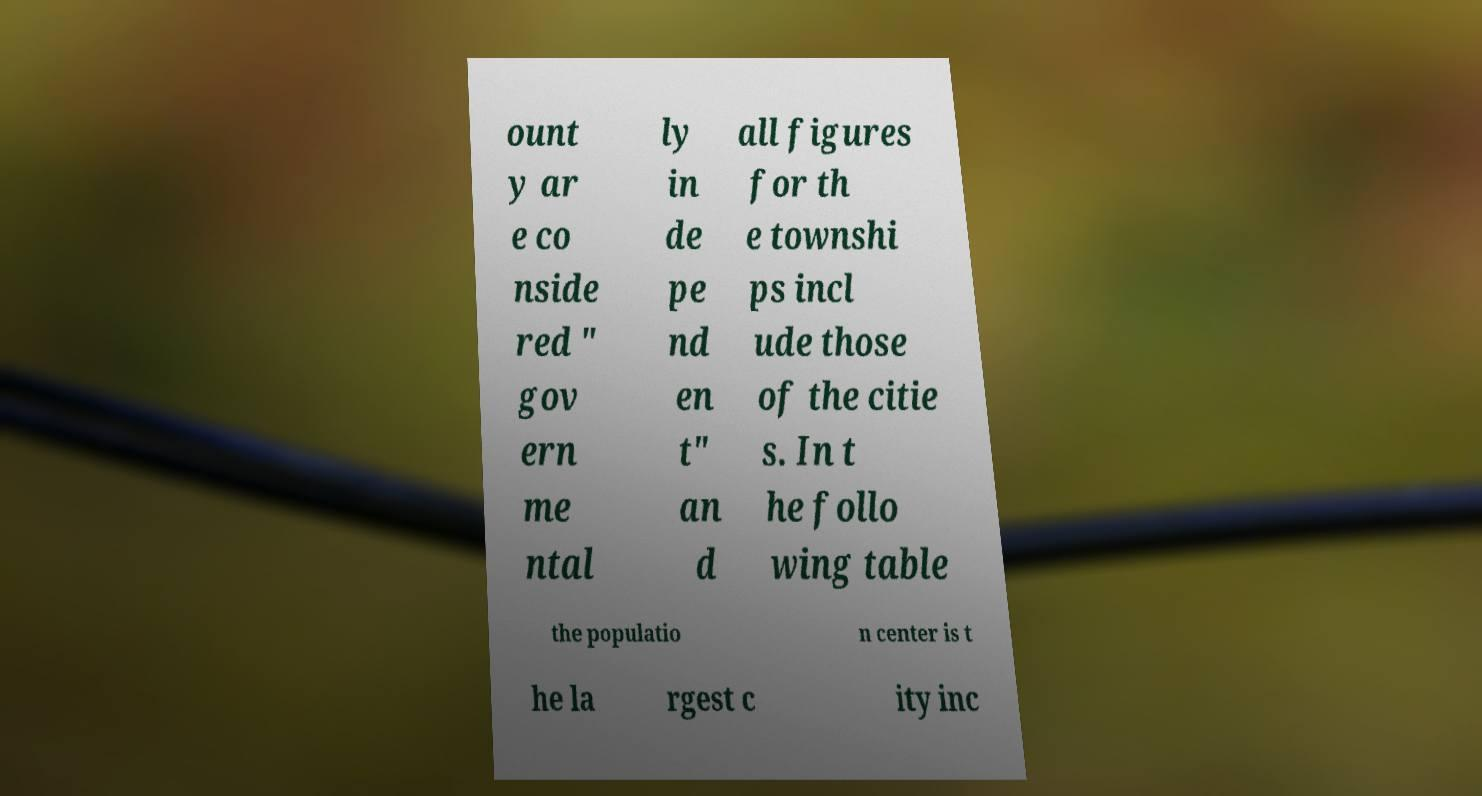Can you read and provide the text displayed in the image?This photo seems to have some interesting text. Can you extract and type it out for me? ount y ar e co nside red " gov ern me ntal ly in de pe nd en t" an d all figures for th e townshi ps incl ude those of the citie s. In t he follo wing table the populatio n center is t he la rgest c ity inc 